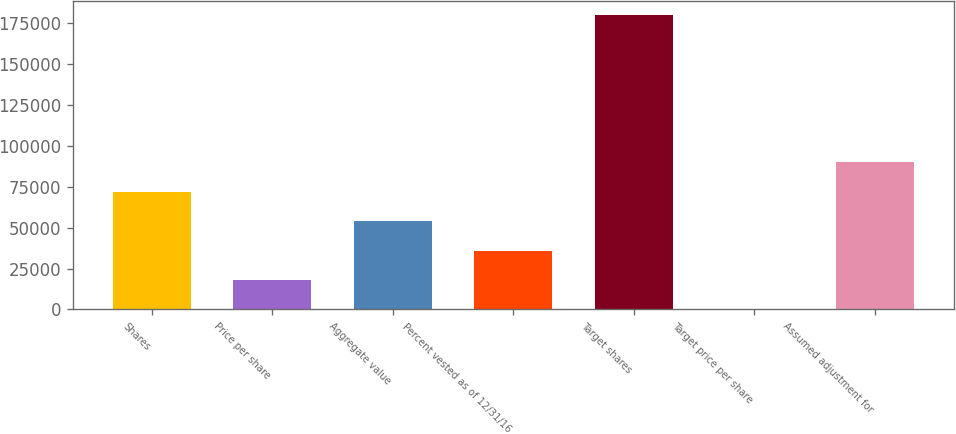Convert chart. <chart><loc_0><loc_0><loc_500><loc_500><bar_chart><fcel>Shares<fcel>Price per share<fcel>Aggregate value<fcel>Percent vested as of 12/31/16<fcel>Target shares<fcel>Target price per share<fcel>Assumed adjustment for<nl><fcel>71832.2<fcel>17998.2<fcel>53887.5<fcel>35942.9<fcel>179500<fcel>53.61<fcel>89776.8<nl></chart> 